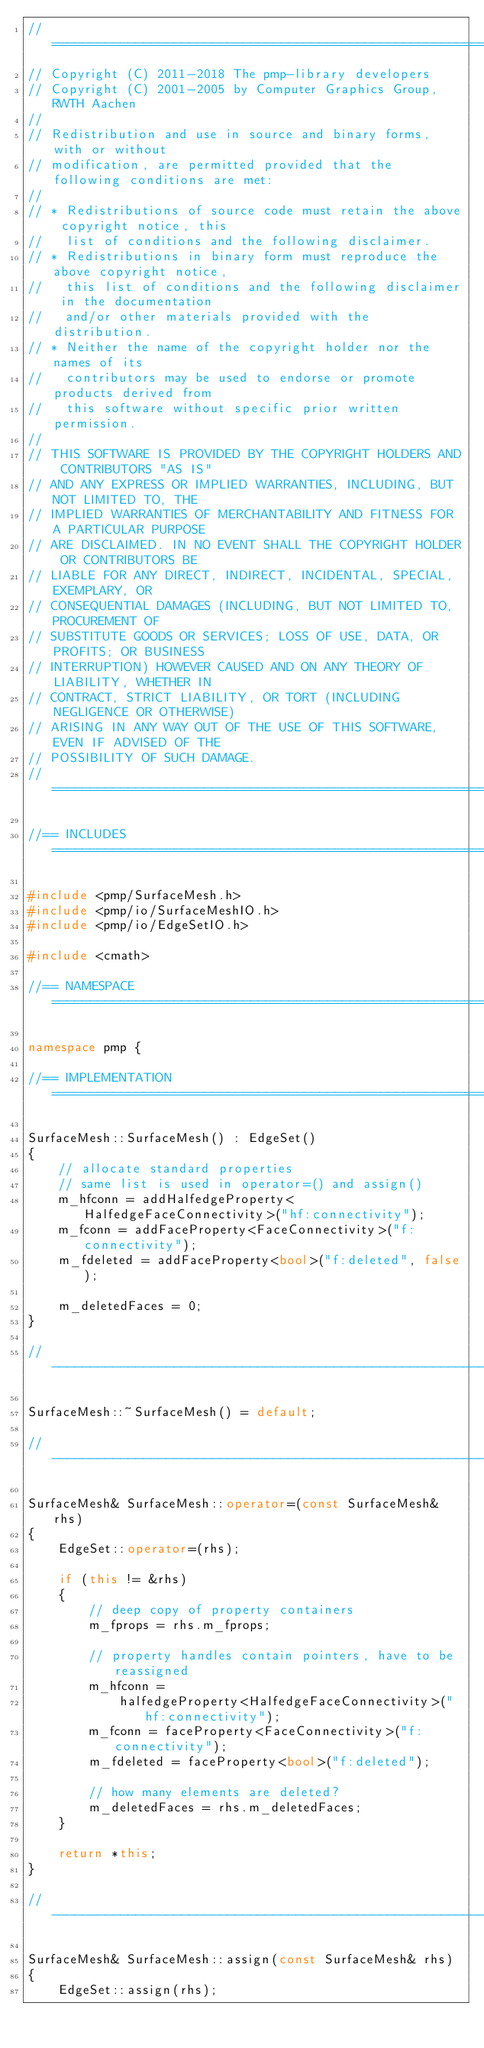Convert code to text. <code><loc_0><loc_0><loc_500><loc_500><_C++_>//=============================================================================
// Copyright (C) 2011-2018 The pmp-library developers
// Copyright (C) 2001-2005 by Computer Graphics Group, RWTH Aachen
//
// Redistribution and use in source and binary forms, with or without
// modification, are permitted provided that the following conditions are met:
//
// * Redistributions of source code must retain the above copyright notice, this
//   list of conditions and the following disclaimer.
// * Redistributions in binary form must reproduce the above copyright notice,
//   this list of conditions and the following disclaimer in the documentation
//   and/or other materials provided with the distribution.
// * Neither the name of the copyright holder nor the names of its
//   contributors may be used to endorse or promote products derived from
//   this software without specific prior written permission.
//
// THIS SOFTWARE IS PROVIDED BY THE COPYRIGHT HOLDERS AND CONTRIBUTORS "AS IS"
// AND ANY EXPRESS OR IMPLIED WARRANTIES, INCLUDING, BUT NOT LIMITED TO, THE
// IMPLIED WARRANTIES OF MERCHANTABILITY AND FITNESS FOR A PARTICULAR PURPOSE
// ARE DISCLAIMED. IN NO EVENT SHALL THE COPYRIGHT HOLDER OR CONTRIBUTORS BE
// LIABLE FOR ANY DIRECT, INDIRECT, INCIDENTAL, SPECIAL, EXEMPLARY, OR
// CONSEQUENTIAL DAMAGES (INCLUDING, BUT NOT LIMITED TO, PROCUREMENT OF
// SUBSTITUTE GOODS OR SERVICES; LOSS OF USE, DATA, OR PROFITS; OR BUSINESS
// INTERRUPTION) HOWEVER CAUSED AND ON ANY THEORY OF LIABILITY, WHETHER IN
// CONTRACT, STRICT LIABILITY, OR TORT (INCLUDING NEGLIGENCE OR OTHERWISE)
// ARISING IN ANY WAY OUT OF THE USE OF THIS SOFTWARE, EVEN IF ADVISED OF THE
// POSSIBILITY OF SUCH DAMAGE.
//=============================================================================

//== INCLUDES =================================================================

#include <pmp/SurfaceMesh.h>
#include <pmp/io/SurfaceMeshIO.h>
#include <pmp/io/EdgeSetIO.h>

#include <cmath>

//== NAMESPACE ================================================================

namespace pmp {

//== IMPLEMENTATION ===========================================================

SurfaceMesh::SurfaceMesh() : EdgeSet()
{
    // allocate standard properties
    // same list is used in operator=() and assign()
    m_hfconn = addHalfedgeProperty<HalfedgeFaceConnectivity>("hf:connectivity");
    m_fconn = addFaceProperty<FaceConnectivity>("f:connectivity");
    m_fdeleted = addFaceProperty<bool>("f:deleted", false);

    m_deletedFaces = 0;
}

//-----------------------------------------------------------------------------

SurfaceMesh::~SurfaceMesh() = default;

//-----------------------------------------------------------------------------

SurfaceMesh& SurfaceMesh::operator=(const SurfaceMesh& rhs)
{
    EdgeSet::operator=(rhs);

    if (this != &rhs)
    {
        // deep copy of property containers
        m_fprops = rhs.m_fprops;

        // property handles contain pointers, have to be reassigned
        m_hfconn =
            halfedgeProperty<HalfedgeFaceConnectivity>("hf:connectivity");
        m_fconn = faceProperty<FaceConnectivity>("f:connectivity");
        m_fdeleted = faceProperty<bool>("f:deleted");

        // how many elements are deleted?
        m_deletedFaces = rhs.m_deletedFaces;
    }

    return *this;
}

//-----------------------------------------------------------------------------

SurfaceMesh& SurfaceMesh::assign(const SurfaceMesh& rhs)
{
    EdgeSet::assign(rhs);
</code> 